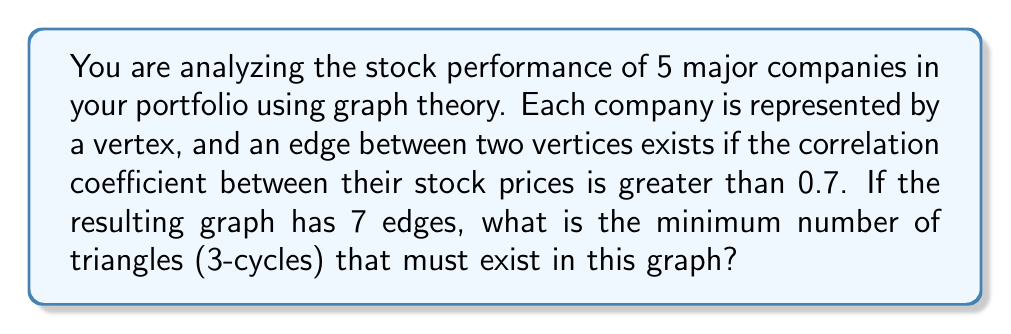Solve this math problem. Let's approach this step-by-step:

1) First, recall that in a simple graph with $n$ vertices, the maximum number of edges is $\binom{n}{2} = \frac{n(n-1)}{2}$.

2) In this case, $n = 5$, so the maximum number of edges is $\binom{5}{2} = 10$.

3) The graph has 7 edges, which is close to the maximum possible. This suggests a high degree of connectivity.

4) To minimize the number of triangles, we want to distribute these 7 edges as evenly as possible among the 5 vertices.

5) The most even distribution possible is for two vertices to have degree 3, and three vertices to have degree 2. This is because:
   $$(3 + 3 + 2 + 2 + 2) / 2 = 7$$

6) Let's call the two vertices of degree 3 as A and B. They must be connected to each other and to at least two of the other three vertices.

7) This forces at least one triangle to exist (A-B and two common neighbors).

8) The remaining edge must connect to either A or B (as they have degree 3), forming another triangle.

9) Therefore, the minimum number of triangles is 2.

This can be verified using Turan's theorem, which states that a graph with $n$ vertices and $e$ edges must contain at least
$$\frac{n}{3}\left(\frac{2e}{n} - \frac{n-1}{2}\right)$$
triangles.

Plugging in $n=5$ and $e=7$, we get:
$$\frac{5}{3}\left(\frac{2(7)}{5} - \frac{5-1}{2}\right) = \frac{5}{3}\left(\frac{14}{5} - 2\right) = \frac{5}{3}\left(\frac{4}{5}\right) = \frac{4}{3}$$

Since the number of triangles must be an integer, this confirms that the minimum number is indeed 2.
Answer: 2 triangles 